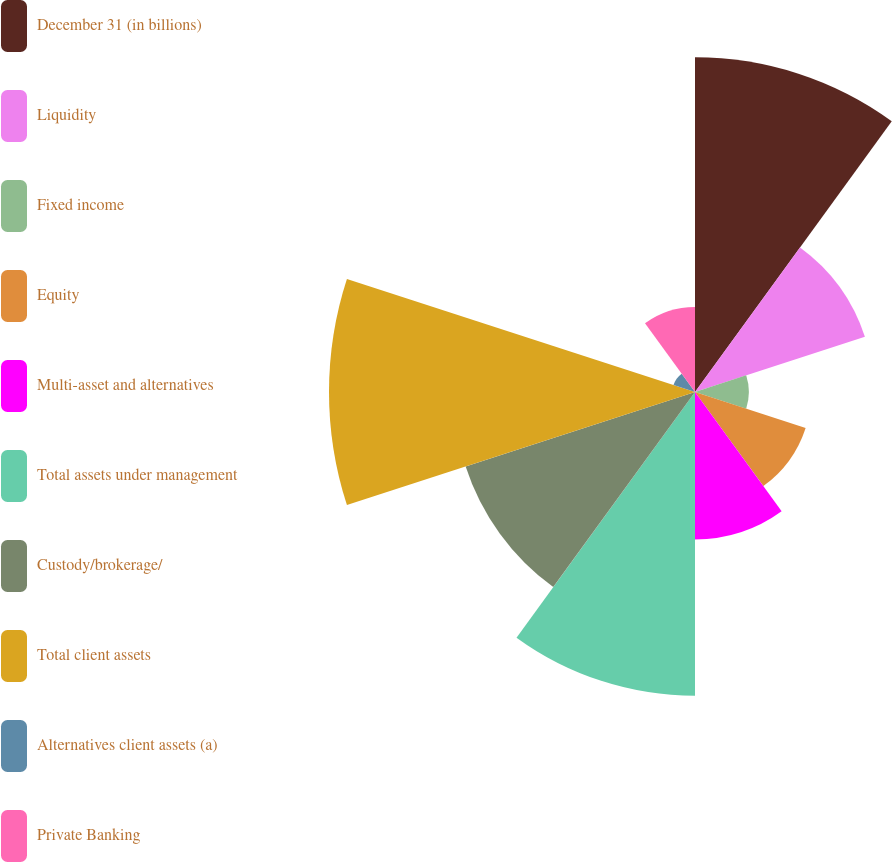Convert chart to OTSL. <chart><loc_0><loc_0><loc_500><loc_500><pie_chart><fcel>December 31 (in billions)<fcel>Liquidity<fcel>Fixed income<fcel>Equity<fcel>Multi-asset and alternatives<fcel>Total assets under management<fcel>Custody/brokerage/<fcel>Total client assets<fcel>Alternatives client assets (a)<fcel>Private Banking<nl><fcel>18.1%<fcel>9.66%<fcel>2.91%<fcel>6.29%<fcel>7.97%<fcel>16.42%<fcel>13.04%<fcel>19.79%<fcel>1.22%<fcel>4.6%<nl></chart> 